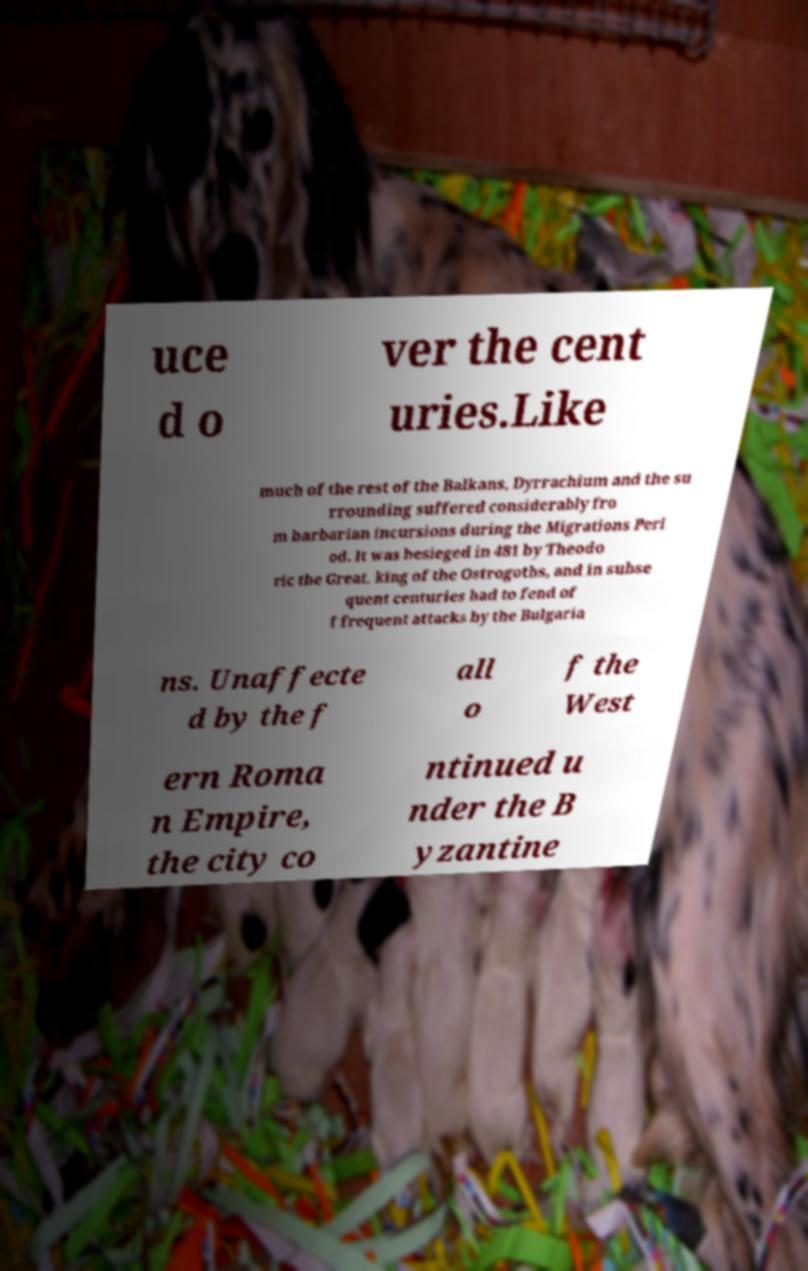There's text embedded in this image that I need extracted. Can you transcribe it verbatim? uce d o ver the cent uries.Like much of the rest of the Balkans, Dyrrachium and the su rrounding suffered considerably fro m barbarian incursions during the Migrations Peri od. It was besieged in 481 by Theodo ric the Great, king of the Ostrogoths, and in subse quent centuries had to fend of f frequent attacks by the Bulgaria ns. Unaffecte d by the f all o f the West ern Roma n Empire, the city co ntinued u nder the B yzantine 